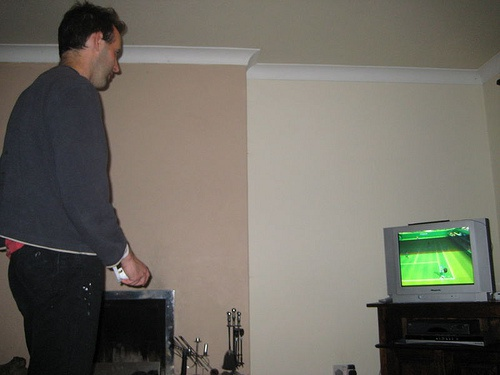Describe the objects in this image and their specific colors. I can see people in black and gray tones, tv in black, gray, lime, and lightgreen tones, and remote in black, lightgray, darkgray, and gray tones in this image. 